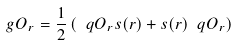Convert formula to latex. <formula><loc_0><loc_0><loc_500><loc_500>\ g O _ { r } = \frac { 1 } { 2 } \left ( \ q O _ { r } s ( r ) + s ( r ) \ q O _ { r } \right )</formula> 